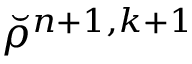Convert formula to latex. <formula><loc_0><loc_0><loc_500><loc_500>\breve { \rho } ^ { n + 1 , k + 1 }</formula> 